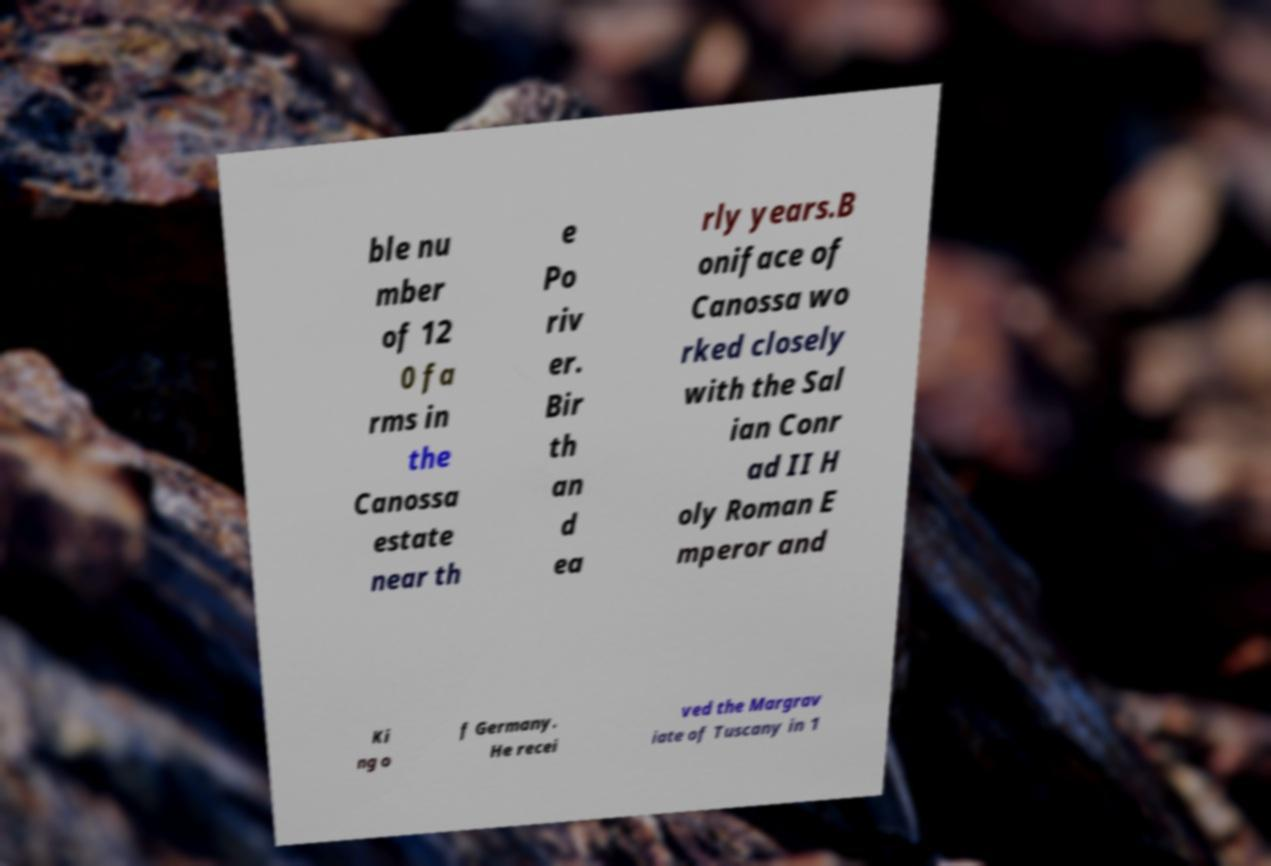There's text embedded in this image that I need extracted. Can you transcribe it verbatim? ble nu mber of 12 0 fa rms in the Canossa estate near th e Po riv er. Bir th an d ea rly years.B oniface of Canossa wo rked closely with the Sal ian Conr ad II H oly Roman E mperor and Ki ng o f Germany. He recei ved the Margrav iate of Tuscany in 1 